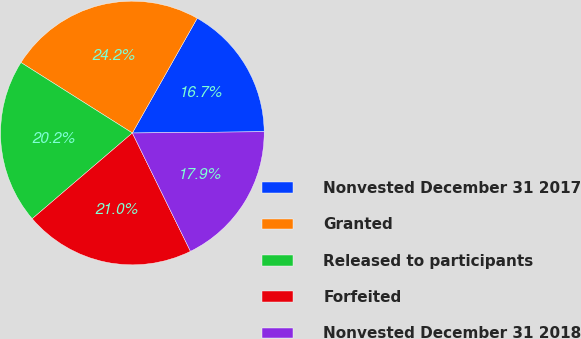Convert chart to OTSL. <chart><loc_0><loc_0><loc_500><loc_500><pie_chart><fcel>Nonvested December 31 2017<fcel>Granted<fcel>Released to participants<fcel>Forfeited<fcel>Nonvested December 31 2018<nl><fcel>16.66%<fcel>24.21%<fcel>20.25%<fcel>21.0%<fcel>17.89%<nl></chart> 